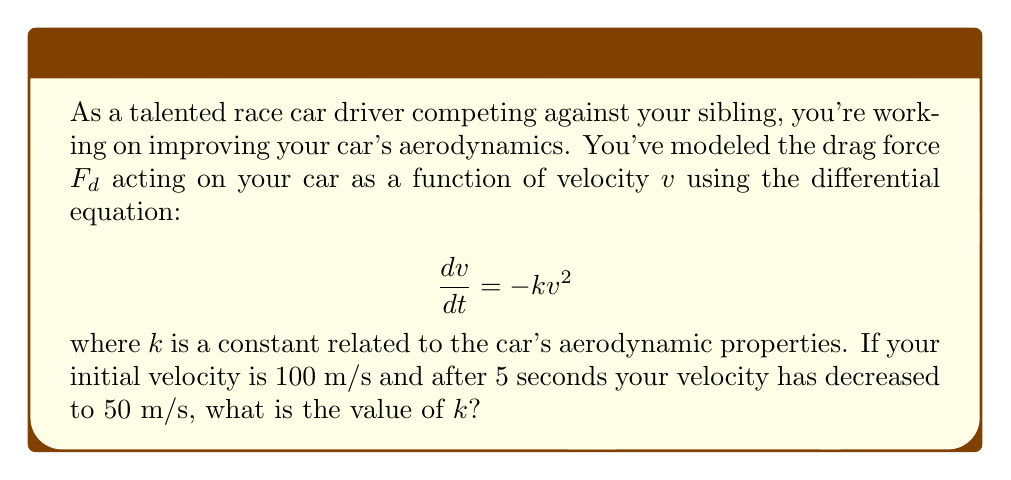Give your solution to this math problem. Let's approach this step-by-step:

1) We start with the differential equation:

   $$\frac{dv}{dt} = -kv^2$$

2) This is a separable differential equation. We can rewrite it as:

   $$\frac{dv}{v^2} = -k dt$$

3) Integrating both sides:

   $$\int \frac{dv}{v^2} = -k \int dt$$

4) This gives us:

   $$-\frac{1}{v} = -kt + C$$

   where $C$ is a constant of integration.

5) We can rewrite this as:

   $$\frac{1}{v} = kt - C$$

6) Now, let's use the initial condition. At $t=0$, $v=100$. Substituting:

   $$\frac{1}{100} = k(0) - C$$

   $$-C = \frac{1}{100}$$

7) Now we can write our general solution:

   $$\frac{1}{v} = kt + \frac{1}{100}$$

8) At $t=5$, $v=50$. Let's substitute these values:

   $$\frac{1}{50} = 5k + \frac{1}{100}$$

9) Solving for $k$:

   $$\frac{1}{50} - \frac{1}{100} = 5k$$
   
   $$\frac{2}{100} - \frac{1}{100} = 5k$$
   
   $$\frac{1}{100} = 5k$$
   
   $$k = \frac{1}{500} = 0.002$$

Therefore, the value of $k$ is 0.002 s/m.
Answer: $k = 0.002$ s/m 